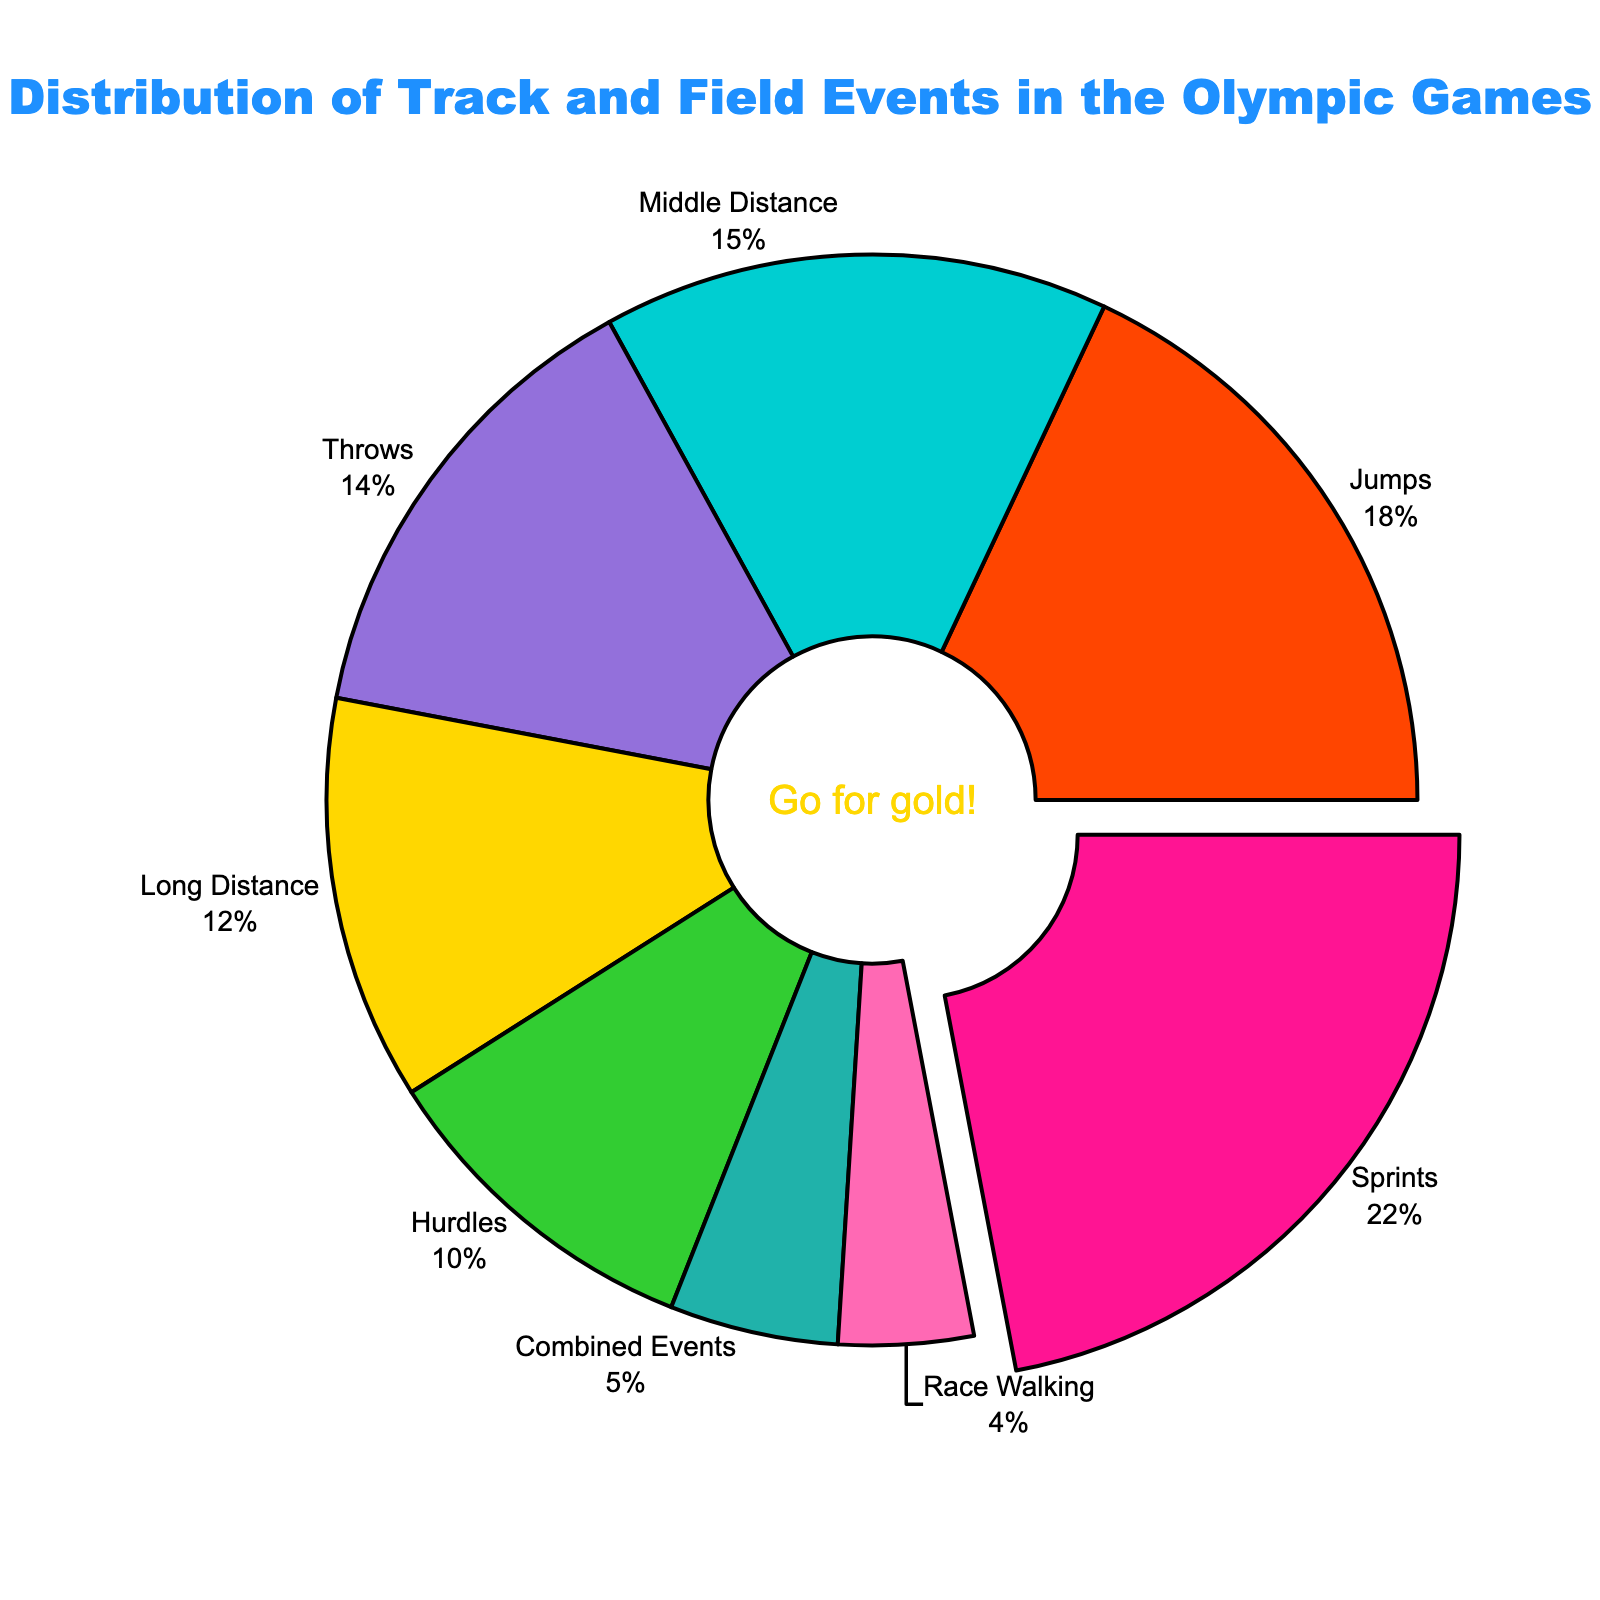Which event has the highest percentage of distribution in track and field events in the Olympic Games? The event with the highest percentage is highlighted by being slightly pulled out from the pie chart. By observing the pulled-out segment and its label, it is clear that the Sprints event has the highest percentage.
Answer: Sprints What is the combined percentage of the Sprints and Jumps events? To find the combined percentage, add the individual percentages of the Sprints and Jumps events. Sprints is 22% and Jumps is 18%, so: 22% + 18% = 40%.
Answer: 40% Which disciplines account for less than 10% of the distribution? By looking at the pie chart labels and their associated percentages, identify which are less than 10%. Here we see that Combined Events and Race Walking have percentages of 5% and 4% respectively.
Answer: Combined Events and Race Walking How much more does the Throws event contribute compared to the Race Walking event? Subtract the percentage of the Race Walking event from the percentage of the Throws event to find the difference. Throws is 14%, and Race Walking is 4%, so: 14% - 4% = 10%.
Answer: 10% What is the total percentage contribution of all running-related events (Sprints, Middle Distance, Long Distance, and Hurdles)? Sum the percentages of all the running-related events. Sprints is 22%, Middle Distance is 15%, Long Distance is 12%, and Hurdles is 10%. So, the sum is: 22% + 15% + 12% + 10% = 59%.
Answer: 59% Which events have almost the same percentage distribution, differing by 1% only? Compare the labels and their percentages to see which two events have a 1% difference. Middle Distance is 15%, and Throws is 14%, making the difference: 15% - 14% = 1%.
Answer: Middle Distance and Throws What color represents the Throws event in the pie chart? Identify the color used for the Throws event by looking at its corresponding segment in the pie chart. The Throws event is represented by a purple color.
Answer: Purple What's the percentage difference between Jumps and Long Distance events? Subtract the percentage of the Long Distance event from the percentage of the Jumps event. Jumps is 18% and Long Distance is 12%, so: 18% - 12% = 6%.
Answer: 6% Among the running events (Sprints, Middle Distance, Long Distance, Hurdles), which one has the lowest percentage? Look at the four running events and compare their percentages. Hurdles has the lowest percentage at 10%.
Answer: Hurdles What is the average percentage of Jumps, Throws, and Combined Events? Sum the percentages of Jumps, Throws, and Combined Events, and then divide by the number of events. Jumps is 18%, Throws is 14%, and Combined Events is 5%. So, (18% + 14% + 5%) / 3 = 12.33%.
Answer: ~12.33% 